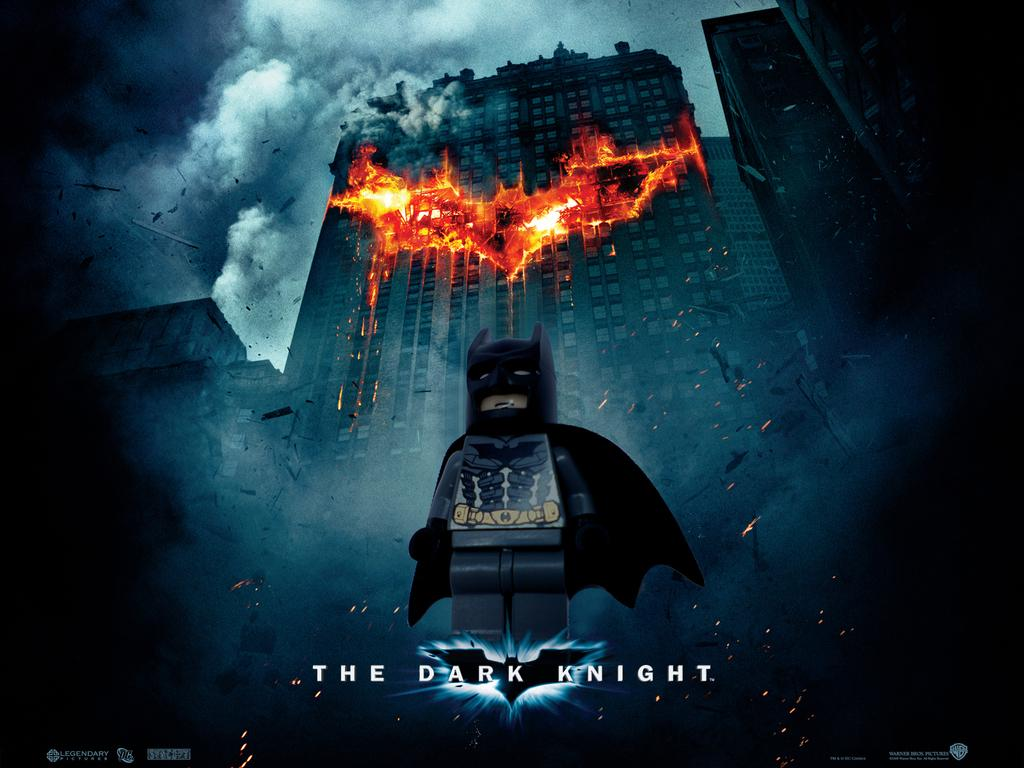<image>
Share a concise interpretation of the image provided. An advertisement for the Lego version of The Dark knights shows Lego Batman. 